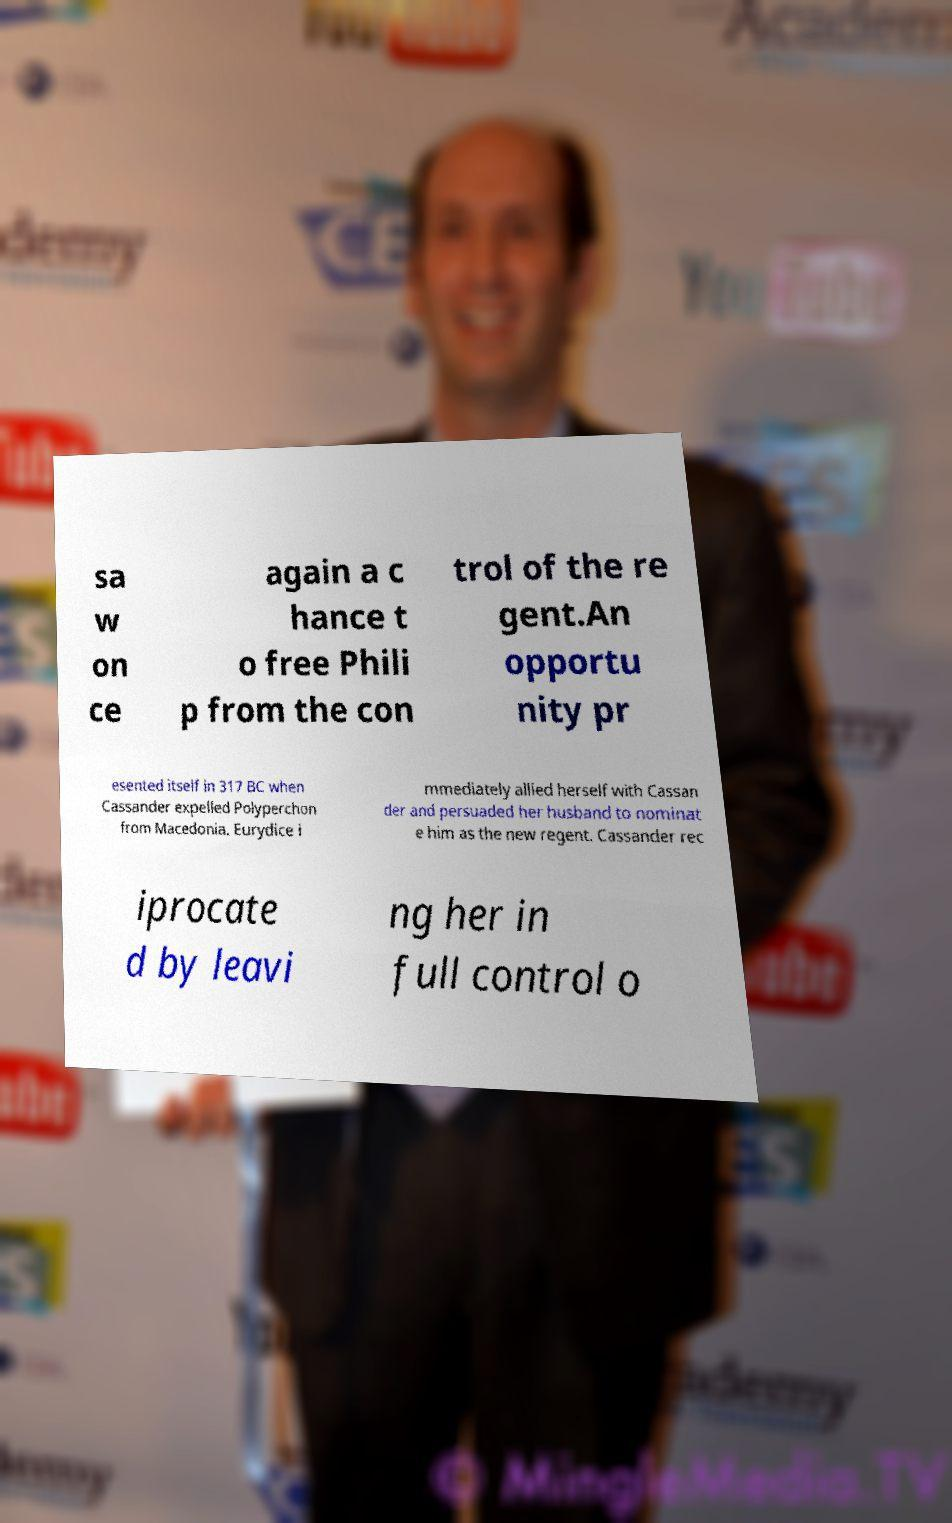Could you extract and type out the text from this image? sa w on ce again a c hance t o free Phili p from the con trol of the re gent.An opportu nity pr esented itself in 317 BC when Cassander expelled Polyperchon from Macedonia. Eurydice i mmediately allied herself with Cassan der and persuaded her husband to nominat e him as the new regent. Cassander rec iprocate d by leavi ng her in full control o 